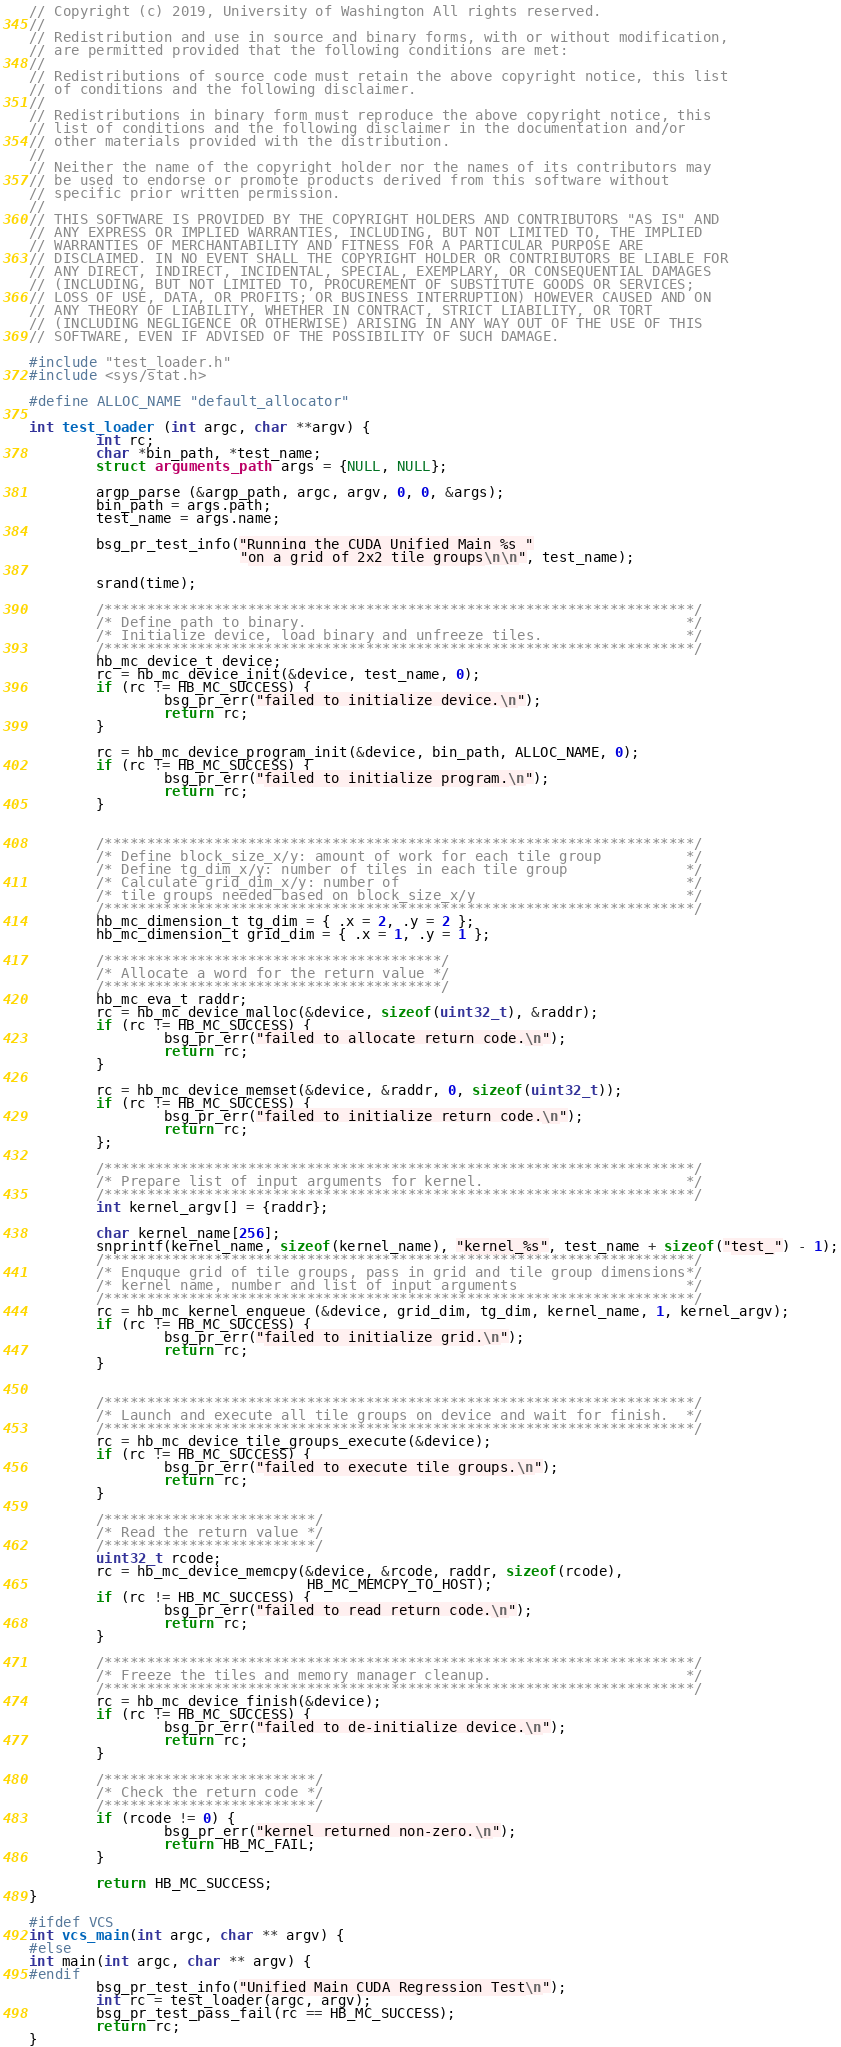<code> <loc_0><loc_0><loc_500><loc_500><_C_>// Copyright (c) 2019, University of Washington All rights reserved.
// 
// Redistribution and use in source and binary forms, with or without modification,
// are permitted provided that the following conditions are met:
// 
// Redistributions of source code must retain the above copyright notice, this list
// of conditions and the following disclaimer.
// 
// Redistributions in binary form must reproduce the above copyright notice, this
// list of conditions and the following disclaimer in the documentation and/or
// other materials provided with the distribution.
// 
// Neither the name of the copyright holder nor the names of its contributors may
// be used to endorse or promote products derived from this software without
// specific prior written permission.
// 
// THIS SOFTWARE IS PROVIDED BY THE COPYRIGHT HOLDERS AND CONTRIBUTORS "AS IS" AND
// ANY EXPRESS OR IMPLIED WARRANTIES, INCLUDING, BUT NOT LIMITED TO, THE IMPLIED
// WARRANTIES OF MERCHANTABILITY AND FITNESS FOR A PARTICULAR PURPOSE ARE
// DISCLAIMED. IN NO EVENT SHALL THE COPYRIGHT HOLDER OR CONTRIBUTORS BE LIABLE FOR
// ANY DIRECT, INDIRECT, INCIDENTAL, SPECIAL, EXEMPLARY, OR CONSEQUENTIAL DAMAGES
// (INCLUDING, BUT NOT LIMITED TO, PROCUREMENT OF SUBSTITUTE GOODS OR SERVICES;
// LOSS OF USE, DATA, OR PROFITS; OR BUSINESS INTERRUPTION) HOWEVER CAUSED AND ON
// ANY THEORY OF LIABILITY, WHETHER IN CONTRACT, STRICT LIABILITY, OR TORT
// (INCLUDING NEGLIGENCE OR OTHERWISE) ARISING IN ANY WAY OUT OF THE USE OF THIS
// SOFTWARE, EVEN IF ADVISED OF THE POSSIBILITY OF SUCH DAMAGE.

#include "test_loader.h"
#include <sys/stat.h>

#define ALLOC_NAME "default_allocator"

int test_loader (int argc, char **argv) {
        int rc;
        char *bin_path, *test_name;
        struct arguments_path args = {NULL, NULL};

        argp_parse (&argp_path, argc, argv, 0, 0, &args);
        bin_path = args.path;
        test_name = args.name;

        bsg_pr_test_info("Running the CUDA Unified Main %s "
                         "on a grid of 2x2 tile groups\n\n", test_name);

        srand(time);

        /**********************************************************************/
        /* Define path to binary.                                             */
        /* Initialize device, load binary and unfreeze tiles.                 */
        /**********************************************************************/
        hb_mc_device_t device;
        rc = hb_mc_device_init(&device, test_name, 0);
        if (rc != HB_MC_SUCCESS) { 
                bsg_pr_err("failed to initialize device.\n");
                return rc;
        }
        
        rc = hb_mc_device_program_init(&device, bin_path, ALLOC_NAME, 0);
        if (rc != HB_MC_SUCCESS) { 
                bsg_pr_err("failed to initialize program.\n");
                return rc;
        }


        /**********************************************************************/
        /* Define block_size_x/y: amount of work for each tile group          */
        /* Define tg_dim_x/y: number of tiles in each tile group              */
        /* Calculate grid_dim_x/y: number of                                  */
        /* tile groups needed based on block_size_x/y                         */
        /**********************************************************************/
        hb_mc_dimension_t tg_dim = { .x = 2, .y = 2 }; 
        hb_mc_dimension_t grid_dim = { .x = 1, .y = 1 };

        /****************************************/
        /* Allocate a word for the return value */
        /****************************************/
        hb_mc_eva_t raddr;
        rc = hb_mc_device_malloc(&device, sizeof(uint32_t), &raddr);
        if (rc != HB_MC_SUCCESS) {
                bsg_pr_err("failed to allocate return code.\n");
                return rc;
        }

        rc = hb_mc_device_memset(&device, &raddr, 0, sizeof(uint32_t));
        if (rc != HB_MC_SUCCESS) {
                bsg_pr_err("failed to initialize return code.\n");
                return rc;
        };

        /**********************************************************************/
        /* Prepare list of input arguments for kernel.                        */
        /**********************************************************************/
        int kernel_argv[] = {raddr};

        char kernel_name[256];
        snprintf(kernel_name, sizeof(kernel_name), "kernel_%s", test_name + sizeof("test_") - 1);
        /**********************************************************************/
        /* Enquque grid of tile groups, pass in grid and tile group dimensions*/
        /* kernel name, number and list of input arguments                    */
        /**********************************************************************/
        rc = hb_mc_kernel_enqueue (&device, grid_dim, tg_dim, kernel_name, 1, kernel_argv);
        if (rc != HB_MC_SUCCESS) { 
                bsg_pr_err("failed to initialize grid.\n");
                return rc;
        }


        /**********************************************************************/
        /* Launch and execute all tile groups on device and wait for finish.  */ 
        /**********************************************************************/
        rc = hb_mc_device_tile_groups_execute(&device);
        if (rc != HB_MC_SUCCESS) { 
                bsg_pr_err("failed to execute tile groups.\n");
                return rc;
        }       

        /*************************/
        /* Read the return value */
        /*************************/
        uint32_t rcode;
        rc = hb_mc_device_memcpy(&device, &rcode, raddr, sizeof(rcode),
                                 HB_MC_MEMCPY_TO_HOST);
        if (rc != HB_MC_SUCCESS) {
                bsg_pr_err("failed to read return code.\n");
                return rc;
        }

        /**********************************************************************/
        /* Freeze the tiles and memory manager cleanup.                       */
        /**********************************************************************/
        rc = hb_mc_device_finish(&device); 
        if (rc != HB_MC_SUCCESS) { 
                bsg_pr_err("failed to de-initialize device.\n");
                return rc;
        }

        /*************************/
        /* Check the return code */
        /*************************/
        if (rcode != 0) {
                bsg_pr_err("kernel returned non-zero.\n");
                return HB_MC_FAIL;
        }

        return HB_MC_SUCCESS;
}

#ifdef VCS
int vcs_main(int argc, char ** argv) {
#else
int main(int argc, char ** argv) {
#endif
        bsg_pr_test_info("Unified Main CUDA Regression Test\n");
        int rc = test_loader(argc, argv);
        bsg_pr_test_pass_fail(rc == HB_MC_SUCCESS);
        return rc;
}


</code> 